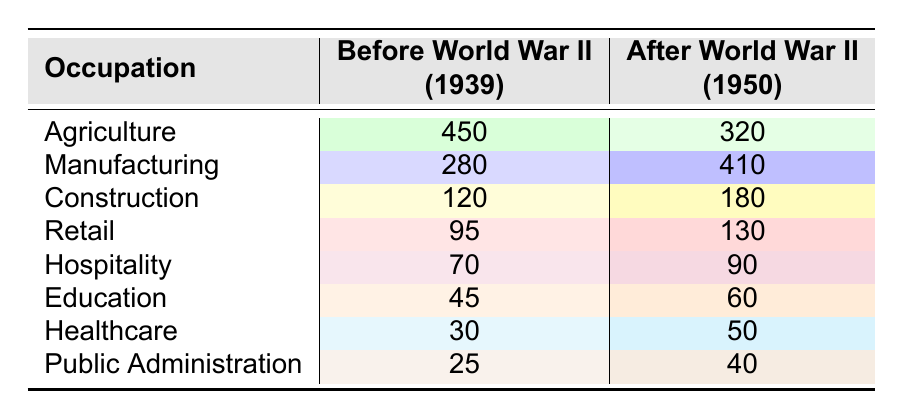What was the number of people employed in agriculture before World War II? The table shows that the number of people employed in agriculture before World War II (1939) was 450.
Answer: 450 What occupation had the highest number of employees after World War II? According to the table, manufacturing had the highest number of employees after World War II (1950) with 410 people.
Answer: Manufacturing What is the difference in the number of people employed in healthcare before and after World War II? In the table, there were 30 people employed in healthcare before World War II (1939) and 50 after the war (1950). The difference is 50 - 30 = 20.
Answer: 20 Was there an increase in employment in the construction sector after World War II? Yes, the table indicates that employment in construction increased from 120 before World War II to 180 after the war.
Answer: Yes What was the total number of people employed in retail and hospitality before World War II? The table shows 95 people employed in retail and 70 in hospitality before World War II. The total is 95 + 70 = 165.
Answer: 165 What percentage increase occurred in the manufacturing sector from before World War II to after? Before World War II, there were 280 employed in manufacturing and 410 after. The increase is 410 - 280 = 130. To find the percentage increase: (130 / 280) * 100 ≈ 46.43%.
Answer: 46.43% Which occupation experienced the least change in the number of employees from before to after World War II? By analyzing the changes, healthcare had an increase of 20 employees and hospitality had an increase of 20 too, but healthcare has the lowest initial count of 30 compared to hospitality's 70. Therefore, healthcare and hospitality experienced the least change together.
Answer: Healthcare (and Hospitality) Calculate the total number of people employed in all sectors combined before World War II. Adding the number of employees in all sectors before World War II: 450 (agriculture) + 280 (manufacturing) + 120 (construction) + 95 (retail) + 70 (hospitality) + 45 (education) + 30 (healthcare) + 25 (public administration) gives a total of 1,115.
Answer: 1115 Did the public administration sector see a decline in employment after World War II? Yes, the table clearly shows that employment in public administration decreased from 25 before to 40 after, indicating a decline.
Answer: No If we were to visually compare agriculture and manufacturing after World War II, which would stand out more? After World War II, manufacturing employs 410 people compared to 320 in agriculture, making manufacturing stand out as having higher employment.
Answer: Manufacturing 